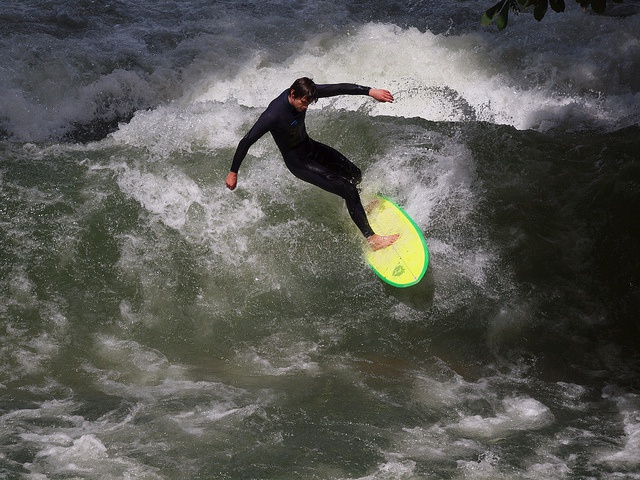Describe the objects in this image and their specific colors. I can see people in darkblue, black, gray, darkgray, and brown tones and surfboard in darkblue, khaki, and tan tones in this image. 